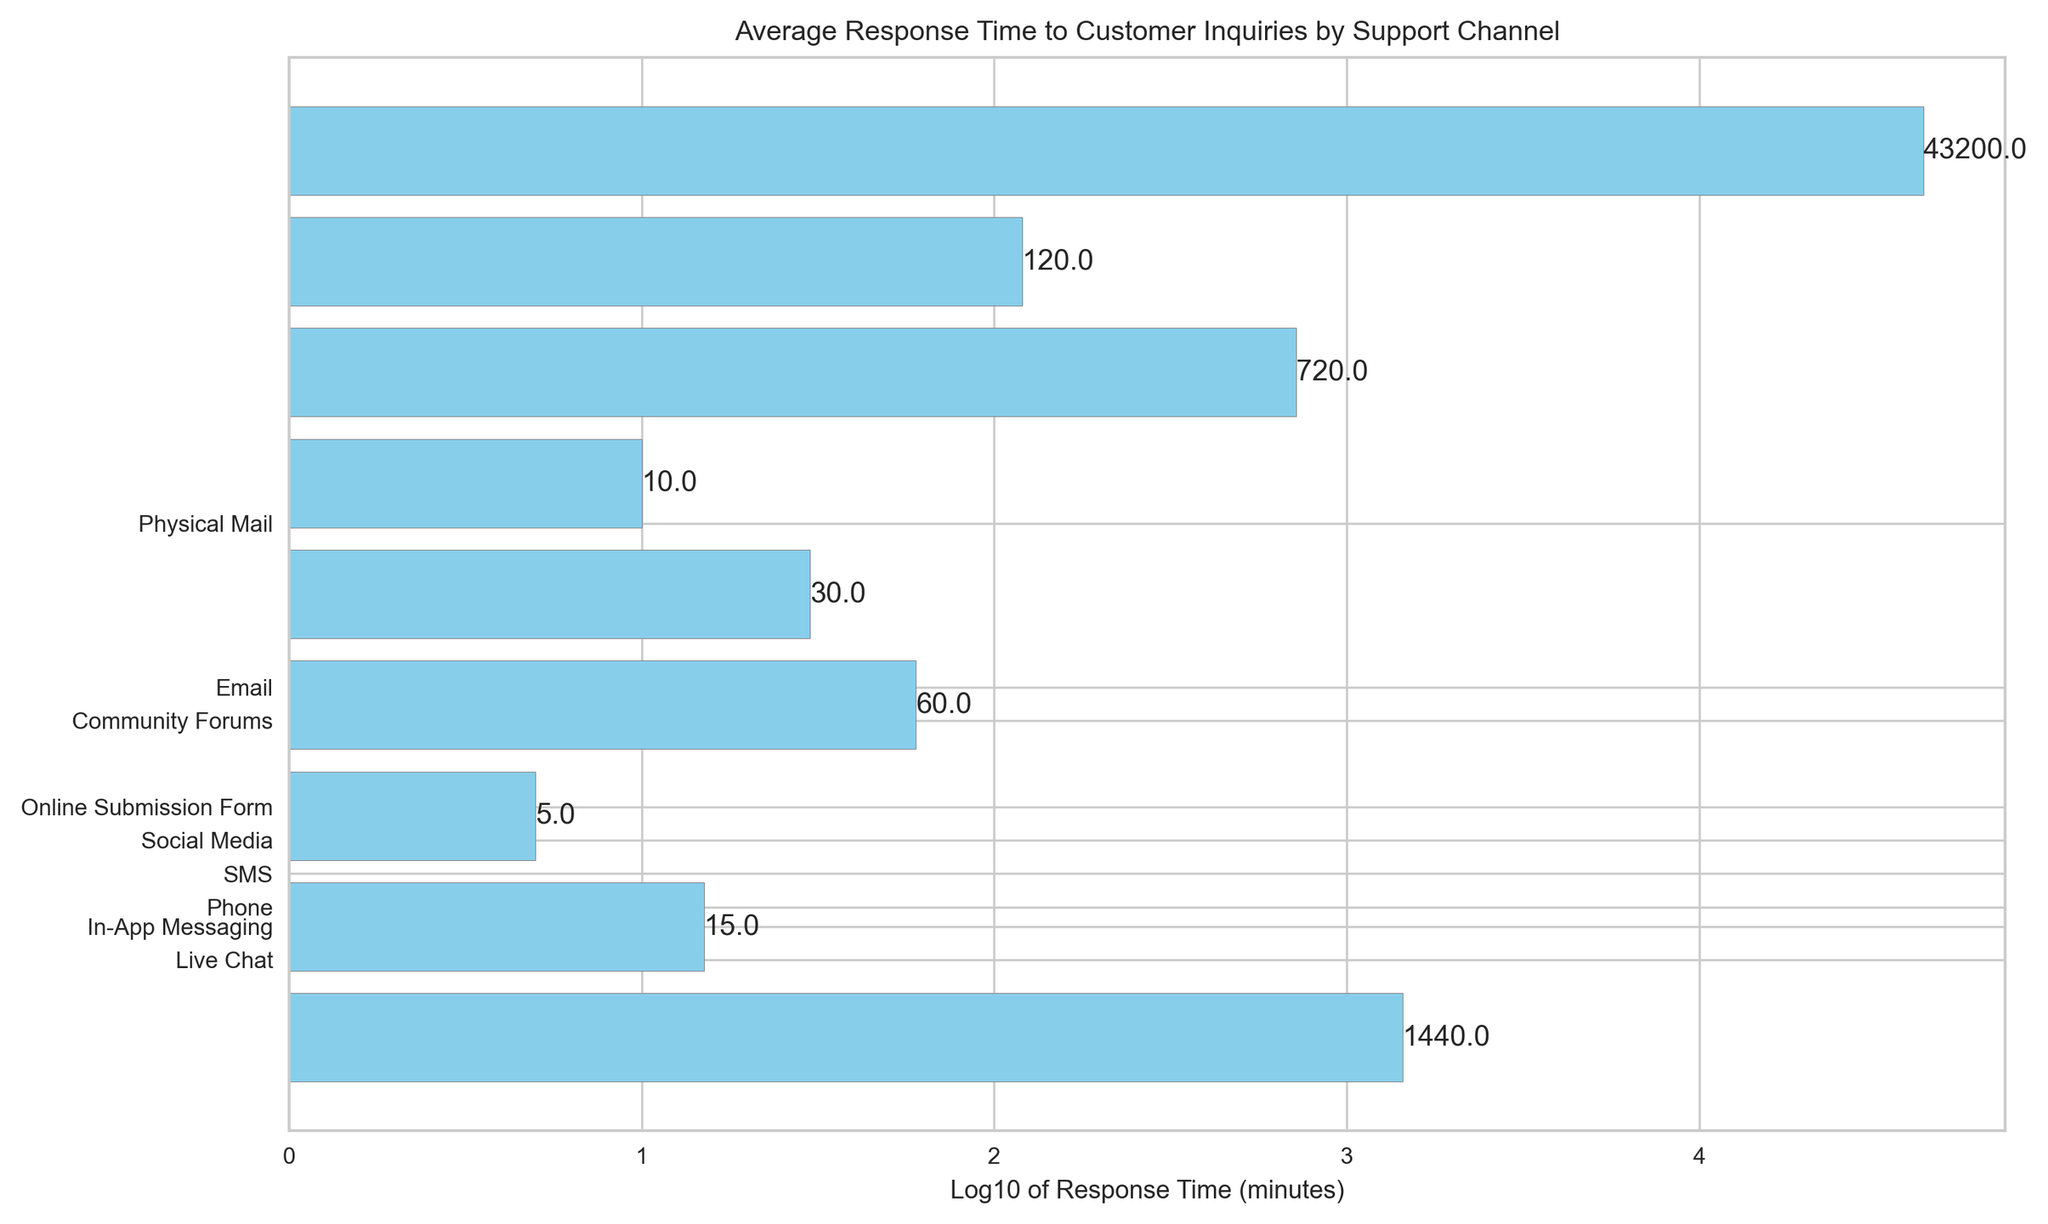Which support channel has the fastest response time? The fastest response time can be determined by looking at the bar that represents the smallest value on the horizontal axis. In this case, 'Live Chat' has the shortest bar, indicating it has the fastest response time.
Answer: Live Chat Which support channel has the longest response time? The longest response time can be determined by looking at the bar that represents the largest value on the horizontal axis. In this case, 'Physical Mail' has the longest bar, indicating it has the longest response time.
Answer: Physical Mail How does the response time of Email compare to In-App Messaging? Email's response time can be seen by locating the bar labeled 'Email', and In-App Messaging's response time by locating its respective bar. Email has a significantly longer bar than In-App Messaging, indicating a much longer response time.
Answer: Email is slower What is the approximate response time difference between Phone and Social Media? To find the difference, locate the bars for Phone and Social Media. Phone has a response time of around 15 minutes, while Social Media has around 60 minutes. The difference is approximately 60 - 15 = 45 minutes.
Answer: 45 minutes Which support channels have response times within 10 to 20 minutes? Look for bars with values in this range. Phone (15 minutes) and In-App Messaging (10 minutes) fall within the 10 to 20 minutes range.
Answer: Phone, In-App Messaging Which support channel has a response time closest to 1 day (1440 minutes)? Identify the bar that corresponds to around 1440 minutes. In this case, the 'Email' channel has a response time closest to 1440 minutes.
Answer: Email What is the median response time among all channels? To find the median, list all response times in ascending order: 5, 10, 15, 30, 60, 120, 720, 1440, 43200. The middle value is the median, which is 60 minutes (Social Media).
Answer: 60 minutes How many support channels have a response time of an hour or less? Identify all bars that represent response times of 60 minutes or less. They are Live Chat (5), In-App Messaging (10), Phone (15), SMS (30), and Social Media (60), making a total of 5 channels.
Answer: 5 channels 